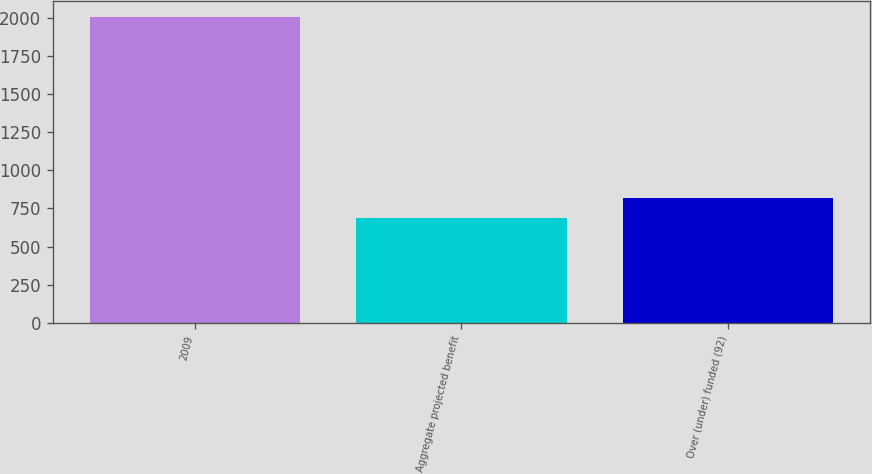<chart> <loc_0><loc_0><loc_500><loc_500><bar_chart><fcel>2009<fcel>Aggregate projected benefit<fcel>Over (under) funded (92)<nl><fcel>2008<fcel>685<fcel>817.3<nl></chart> 